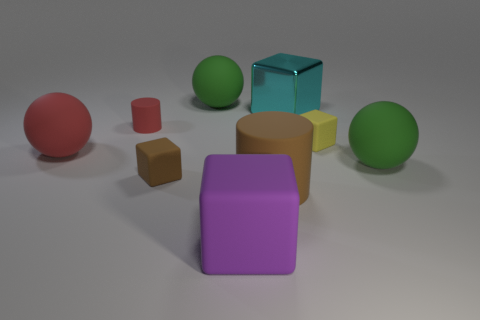Add 1 rubber cylinders. How many objects exist? 10 Subtract all gray blocks. Subtract all red cylinders. How many blocks are left? 4 Subtract all spheres. How many objects are left? 6 Add 3 large blocks. How many large blocks are left? 5 Add 3 red rubber balls. How many red rubber balls exist? 4 Subtract 0 gray cylinders. How many objects are left? 9 Subtract all large brown matte objects. Subtract all big purple blocks. How many objects are left? 7 